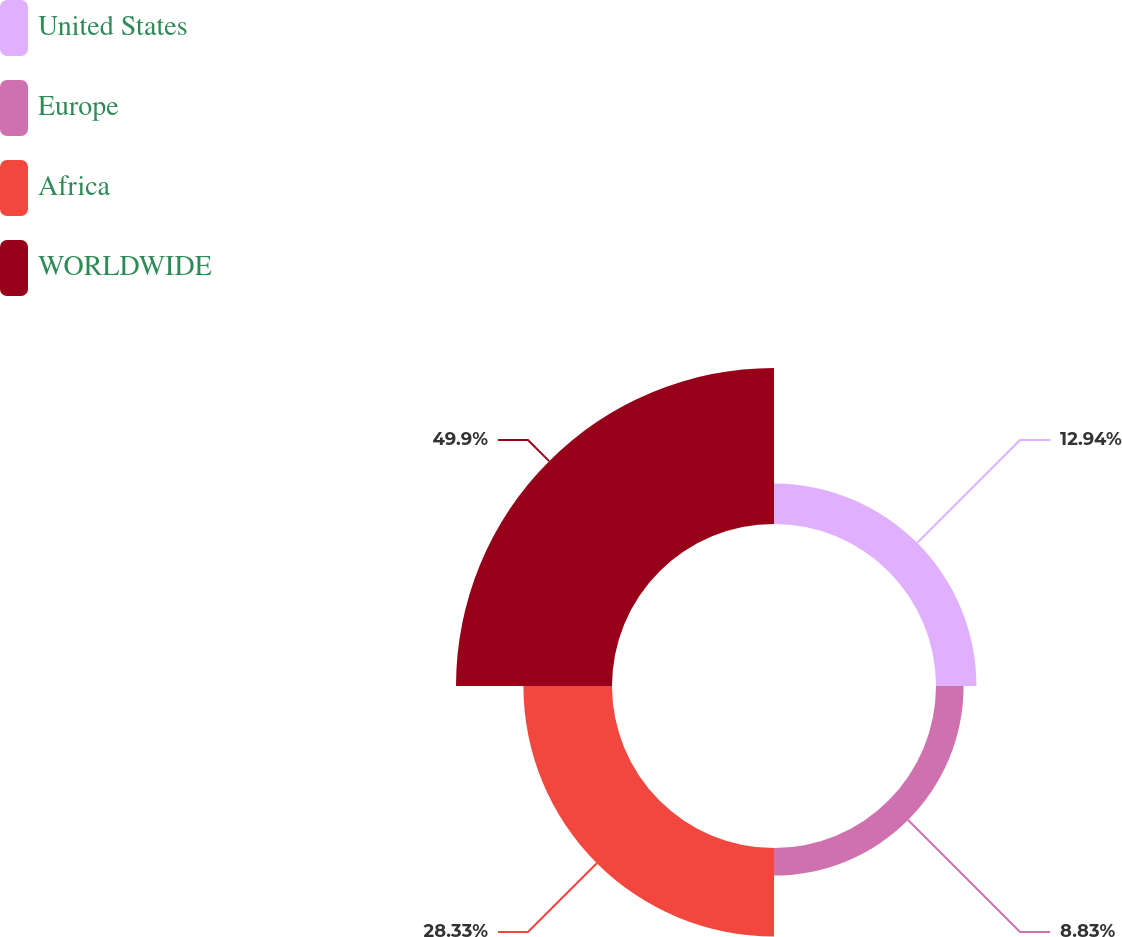Convert chart to OTSL. <chart><loc_0><loc_0><loc_500><loc_500><pie_chart><fcel>United States<fcel>Europe<fcel>Africa<fcel>WORLDWIDE<nl><fcel>12.94%<fcel>8.83%<fcel>28.33%<fcel>49.9%<nl></chart> 